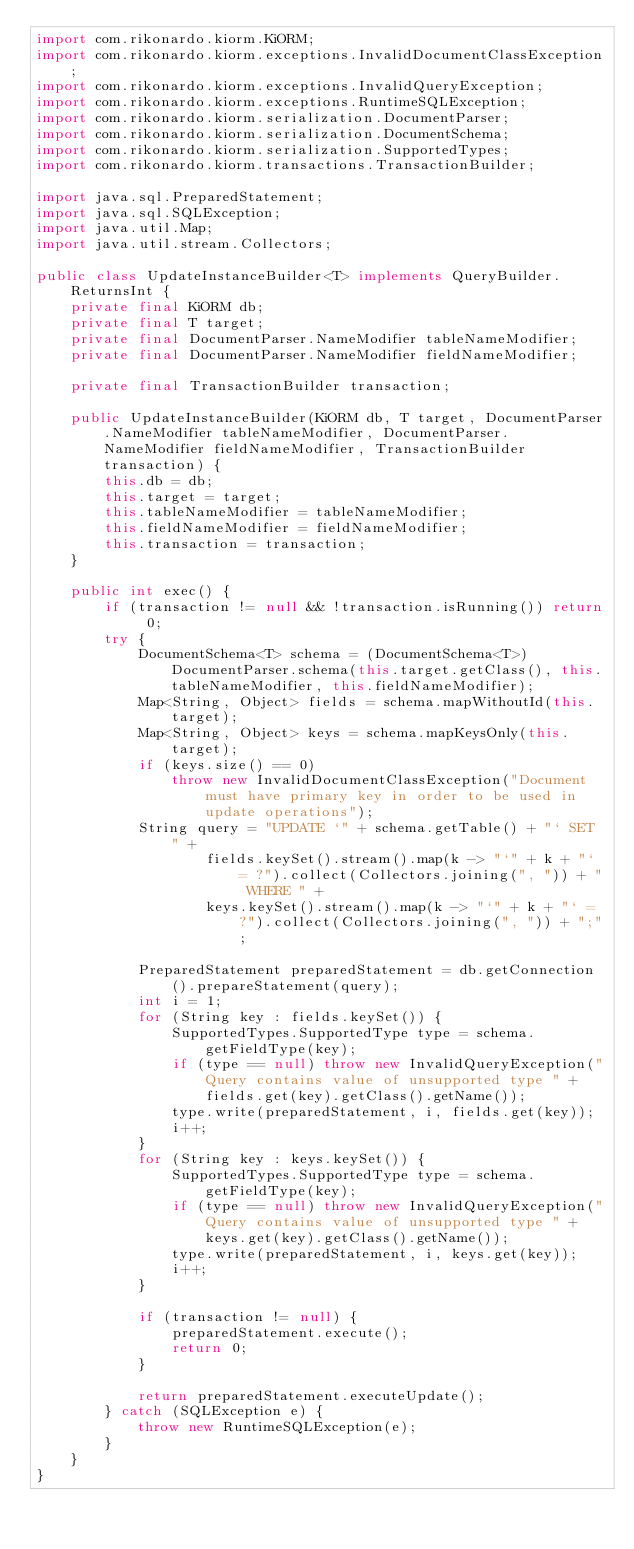<code> <loc_0><loc_0><loc_500><loc_500><_Java_>import com.rikonardo.kiorm.KiORM;
import com.rikonardo.kiorm.exceptions.InvalidDocumentClassException;
import com.rikonardo.kiorm.exceptions.InvalidQueryException;
import com.rikonardo.kiorm.exceptions.RuntimeSQLException;
import com.rikonardo.kiorm.serialization.DocumentParser;
import com.rikonardo.kiorm.serialization.DocumentSchema;
import com.rikonardo.kiorm.serialization.SupportedTypes;
import com.rikonardo.kiorm.transactions.TransactionBuilder;

import java.sql.PreparedStatement;
import java.sql.SQLException;
import java.util.Map;
import java.util.stream.Collectors;

public class UpdateInstanceBuilder<T> implements QueryBuilder.ReturnsInt {
    private final KiORM db;
    private final T target;
    private final DocumentParser.NameModifier tableNameModifier;
    private final DocumentParser.NameModifier fieldNameModifier;

    private final TransactionBuilder transaction;

    public UpdateInstanceBuilder(KiORM db, T target, DocumentParser.NameModifier tableNameModifier, DocumentParser.NameModifier fieldNameModifier, TransactionBuilder transaction) {
        this.db = db;
        this.target = target;
        this.tableNameModifier = tableNameModifier;
        this.fieldNameModifier = fieldNameModifier;
        this.transaction = transaction;
    }

    public int exec() {
        if (transaction != null && !transaction.isRunning()) return 0;
        try {
            DocumentSchema<T> schema = (DocumentSchema<T>) DocumentParser.schema(this.target.getClass(), this.tableNameModifier, this.fieldNameModifier);
            Map<String, Object> fields = schema.mapWithoutId(this.target);
            Map<String, Object> keys = schema.mapKeysOnly(this.target);
            if (keys.size() == 0)
                throw new InvalidDocumentClassException("Document must have primary key in order to be used in update operations");
            String query = "UPDATE `" + schema.getTable() + "` SET " +
                    fields.keySet().stream().map(k -> "`" + k + "` = ?").collect(Collectors.joining(", ")) + " WHERE " +
                    keys.keySet().stream().map(k -> "`" + k + "` = ?").collect(Collectors.joining(", ")) + ";";

            PreparedStatement preparedStatement = db.getConnection().prepareStatement(query);
            int i = 1;
            for (String key : fields.keySet()) {
                SupportedTypes.SupportedType type = schema.getFieldType(key);
                if (type == null) throw new InvalidQueryException("Query contains value of unsupported type " + fields.get(key).getClass().getName());
                type.write(preparedStatement, i, fields.get(key));
                i++;
            }
            for (String key : keys.keySet()) {
                SupportedTypes.SupportedType type = schema.getFieldType(key);
                if (type == null) throw new InvalidQueryException("Query contains value of unsupported type " + keys.get(key).getClass().getName());
                type.write(preparedStatement, i, keys.get(key));
                i++;
            }

            if (transaction != null) {
                preparedStatement.execute();
                return 0;
            }

            return preparedStatement.executeUpdate();
        } catch (SQLException e) {
            throw new RuntimeSQLException(e);
        }
    }
}
</code> 